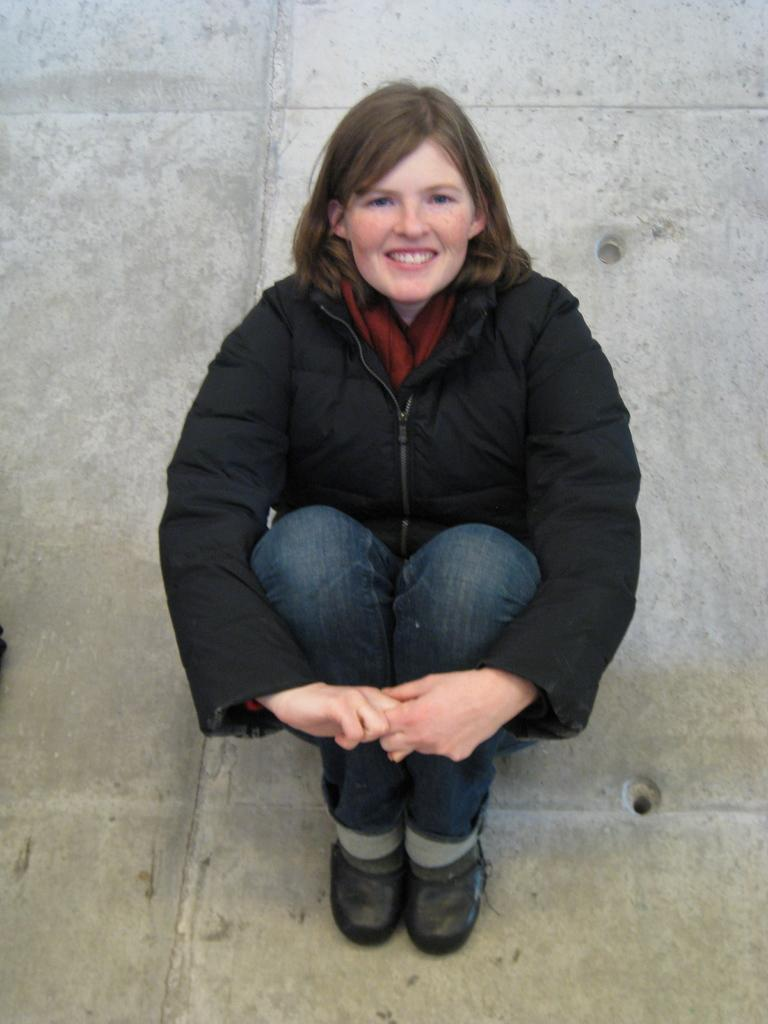Who is the main subject in the picture? There is a woman in the picture. What is the woman doing in the image? The woman is sitting. What type of clothing is the woman wearing? The woman is wearing a coat, jeans, and shoes. What type of tray is the woman holding in the image? There is no tray present in the image; the woman is simply sitting and wearing specific clothing. 